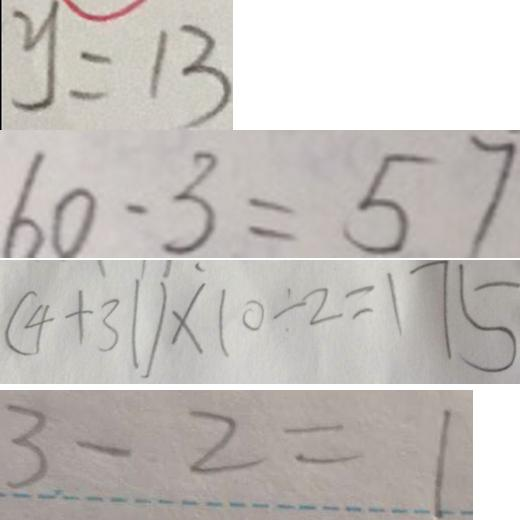Convert formula to latex. <formula><loc_0><loc_0><loc_500><loc_500>y = 1 3 
 6 0 - 3 = 5 7 
 ( 4 + 3 1 ) \times 1 0 \div 2 = 1 7 5 
 3 - 2 = 1</formula> 